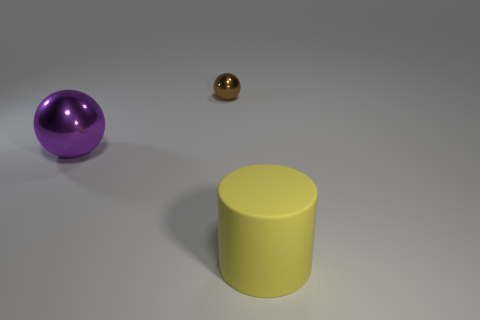Add 3 large metallic objects. How many objects exist? 6 Subtract all spheres. How many objects are left? 1 Subtract 0 gray cylinders. How many objects are left? 3 Subtract all purple shiny spheres. Subtract all purple metal things. How many objects are left? 1 Add 2 large metallic things. How many large metallic things are left? 3 Add 2 yellow rubber things. How many yellow rubber things exist? 3 